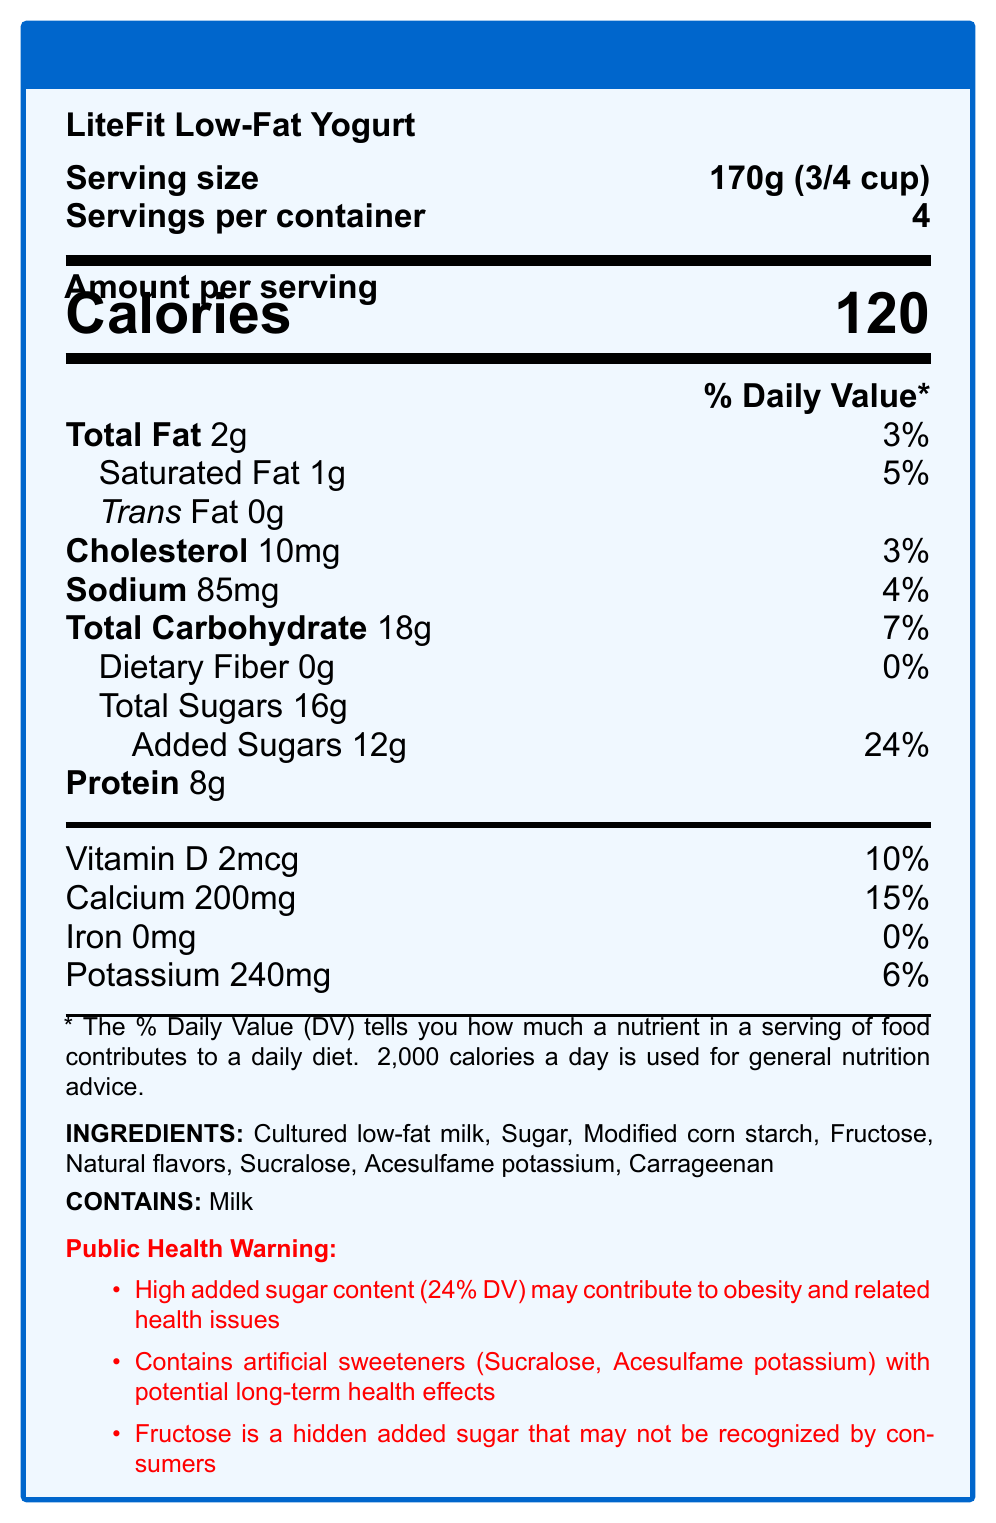what is the serving size of LiteFit Low-Fat Yogurt? The serving size is clearly indicated at the top of the document.
Answer: 170g (3/4 cup) how many calories are in one serving of LiteFit Low-Fat Yogurt? The number of calories per serving is prominently displayed at the top of the document in large font.
Answer: 120 what is the amount of total sugars in one serving? The amount of total sugars is listed under the "Total Carbohydrate" section.
Answer: 16g how much vitamin D is in one serving and what percentage of the daily value does it represent? The vitamin D content and daily value percentage are specified in the vitamin and minerals section.
Answer: 2mcg, 10% what ingredient provides the high added sugar content in LiteFit Low-Fat Yogurt? Both sugar and fructose are listed in the ingredients, contributing to the added sugars.
Answer: Sugar and Fructose how many grams of protein are in one serving? The amount of protein is clearly indicated under the nutrient information.
Answer: 8g look at the public health warning section, what are the highlighted concerns? The public health warning section lists these concerns explicitly.
Answer: High added sugar content, presence of artificial sweeteners, and hidden fructose. how many servings are in one container? A. 2 B. 3 C. 4 D. 5 The number of servings per container is specified at the top of the label.
Answer: C which artificial sweeteners are listed in the ingredients? A. Aspartame and Sucralose B. Saccharin and Stevia C. Sucralose and Acesulfame potassium D. Stevia and Cyclamate The document lists Sucralose and Acesulfame potassium in the ingredients.
Answer: C is there any dietary fiber in LiteFit Low-Fat Yogurt? The document indicates 0g of dietary fiber.
Answer: No is this yogurt suitable for someone allergic to milk? The allergen information explicitly states that it contains milk.
Answer: No summarize the main concerns highlighted by the document. The summary of the main concerns is extracted from the public health warning section, emphasizing the potential health impacts.
Answer: The document warns about the high added sugar content (24% of the daily value) that may contribute to obesity and related health issues, the presence of artificial sweeteners with potential long-term health effects, and the use of fructose, a hidden added sugar. what is the specific long-term health effect risk associated with artificial sweeteners mentioned in the document? The document mentions potential long-term health effects but does not specify what those effects are.
Answer: Not enough information 